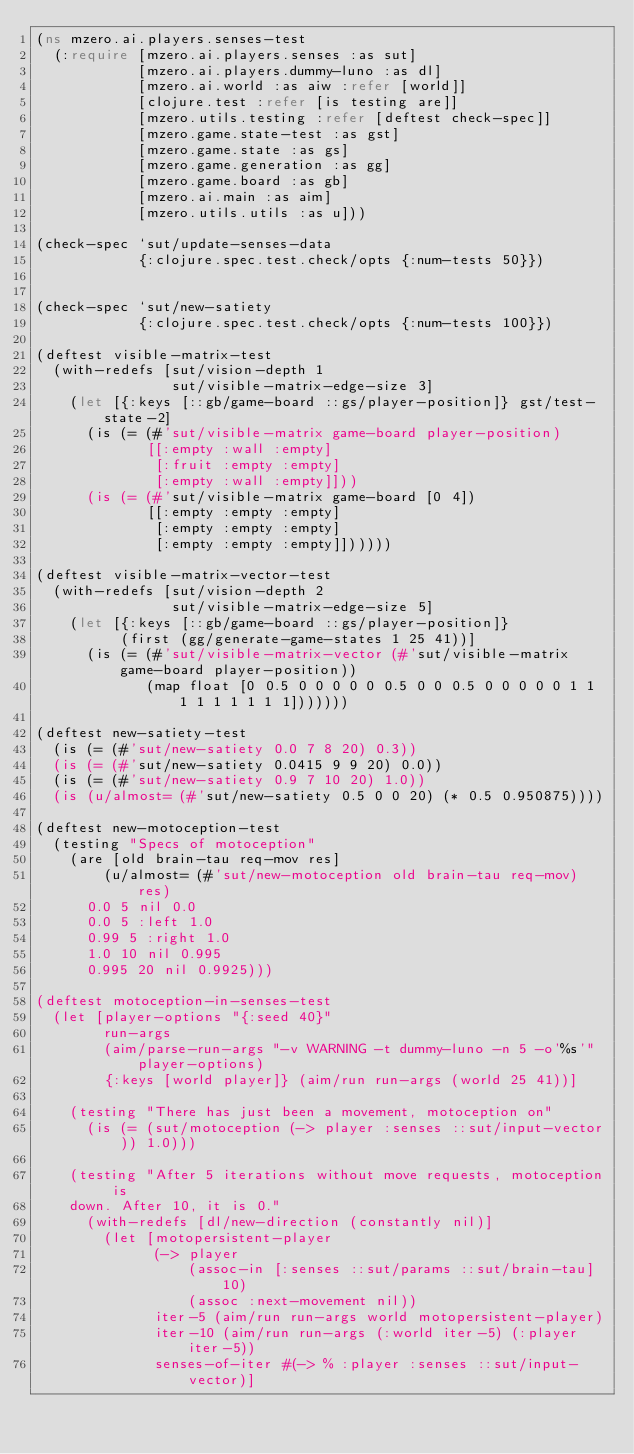Convert code to text. <code><loc_0><loc_0><loc_500><loc_500><_Clojure_>(ns mzero.ai.players.senses-test
  (:require [mzero.ai.players.senses :as sut]
            [mzero.ai.players.dummy-luno :as dl]
            [mzero.ai.world :as aiw :refer [world]]
            [clojure.test :refer [is testing are]]
            [mzero.utils.testing :refer [deftest check-spec]]
            [mzero.game.state-test :as gst]
            [mzero.game.state :as gs]
            [mzero.game.generation :as gg]
            [mzero.game.board :as gb]
            [mzero.ai.main :as aim]
            [mzero.utils.utils :as u]))

(check-spec `sut/update-senses-data
            {:clojure.spec.test.check/opts {:num-tests 50}})


(check-spec `sut/new-satiety
            {:clojure.spec.test.check/opts {:num-tests 100}})

(deftest visible-matrix-test
  (with-redefs [sut/vision-depth 1
                sut/visible-matrix-edge-size 3]
    (let [{:keys [::gb/game-board ::gs/player-position]} gst/test-state-2]
      (is (= (#'sut/visible-matrix game-board player-position)
             [[:empty :wall :empty]
              [:fruit :empty :empty]
              [:empty :wall :empty]]))
      (is (= (#'sut/visible-matrix game-board [0 4])
             [[:empty :empty :empty]
              [:empty :empty :empty]
              [:empty :empty :empty]])))))

(deftest visible-matrix-vector-test
  (with-redefs [sut/vision-depth 2
                sut/visible-matrix-edge-size 5]
    (let [{:keys [::gb/game-board ::gs/player-position]}
          (first (gg/generate-game-states 1 25 41))]
      (is (= (#'sut/visible-matrix-vector (#'sut/visible-matrix game-board player-position))
             (map float [0 0.5 0 0 0 0 0 0.5 0 0 0.5 0 0 0 0 0 1 1 1 1 1 1 1 1 1]))))))

(deftest new-satiety-test
  (is (= (#'sut/new-satiety 0.0 7 8 20) 0.3))
  (is (= (#'sut/new-satiety 0.0415 9 9 20) 0.0))
  (is (= (#'sut/new-satiety 0.9 7 10 20) 1.0))
  (is (u/almost= (#'sut/new-satiety 0.5 0 0 20) (* 0.5 0.950875))))

(deftest new-motoception-test
  (testing "Specs of motoception"
    (are [old brain-tau req-mov res]
        (u/almost= (#'sut/new-motoception old brain-tau req-mov) res)
      0.0 5 nil 0.0
      0.0 5 :left 1.0
      0.99 5 :right 1.0
      1.0 10 nil 0.995
      0.995 20 nil 0.9925)))

(deftest motoception-in-senses-test
  (let [player-options "{:seed 40}"
        run-args
        (aim/parse-run-args "-v WARNING -t dummy-luno -n 5 -o'%s'" player-options)
        {:keys [world player]} (aim/run run-args (world 25 41))]

    (testing "There has just been a movement, motoception on"
      (is (= (sut/motoception (-> player :senses ::sut/input-vector)) 1.0)))

    (testing "After 5 iterations without move requests, motoception is
    down. After 10, it is 0."
      (with-redefs [dl/new-direction (constantly nil)]
        (let [motopersistent-player
              (-> player
                  (assoc-in [:senses ::sut/params ::sut/brain-tau] 10)
                  (assoc :next-movement nil))
              iter-5 (aim/run run-args world motopersistent-player)
              iter-10 (aim/run run-args (:world iter-5) (:player iter-5))
              senses-of-iter #(-> % :player :senses ::sut/input-vector)]</code> 